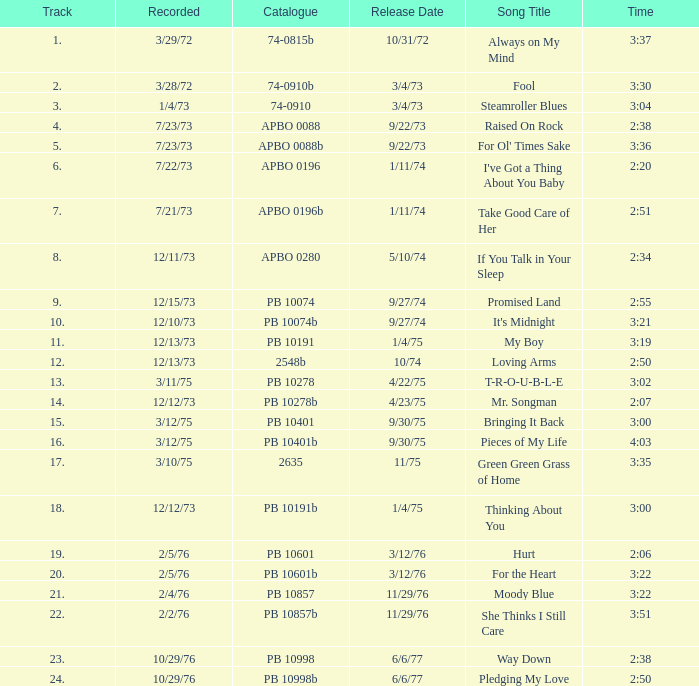Could you inform me about the release date record on october 29th, 1976, and a specific time of 2:50? 6/6/77. 